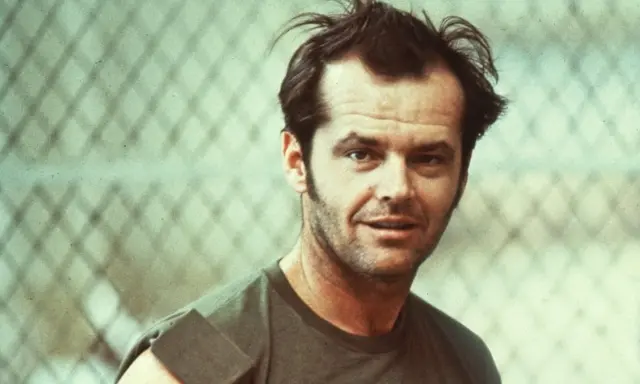Can you describe the main features of this image for me? The image captures a poignant moment featuring a man in his youth, with an intense and thoughtful expression. He wears a casual green tank top, standing in front of a chain-link fence, which adds a gritty, urban touch to the scene. His hair is tousled, complementing the laid-back yet intense ambiance. The image's vintage color tones, coupled with his serious demeanor, convey a sense of nostalgia and depth, hinting at a story behind the casual exterior. 